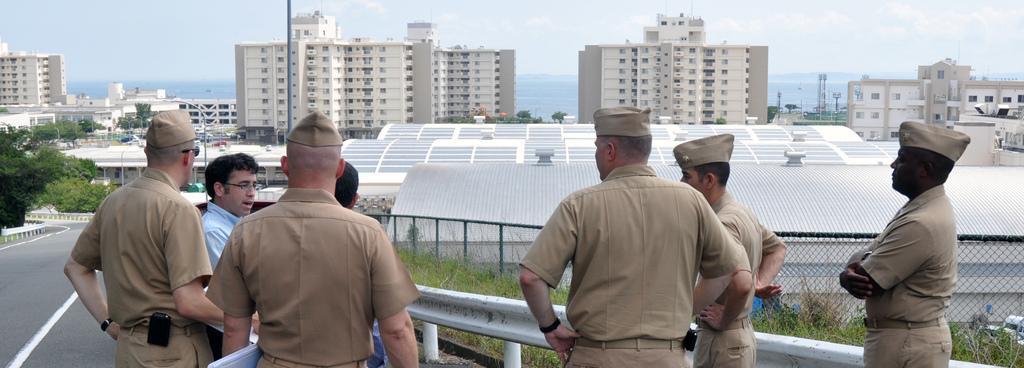How would you summarize this image in a sentence or two? In this image there are few policemen, on the road beside the road there are trees and fencing in the background there are buildings and a sky. 